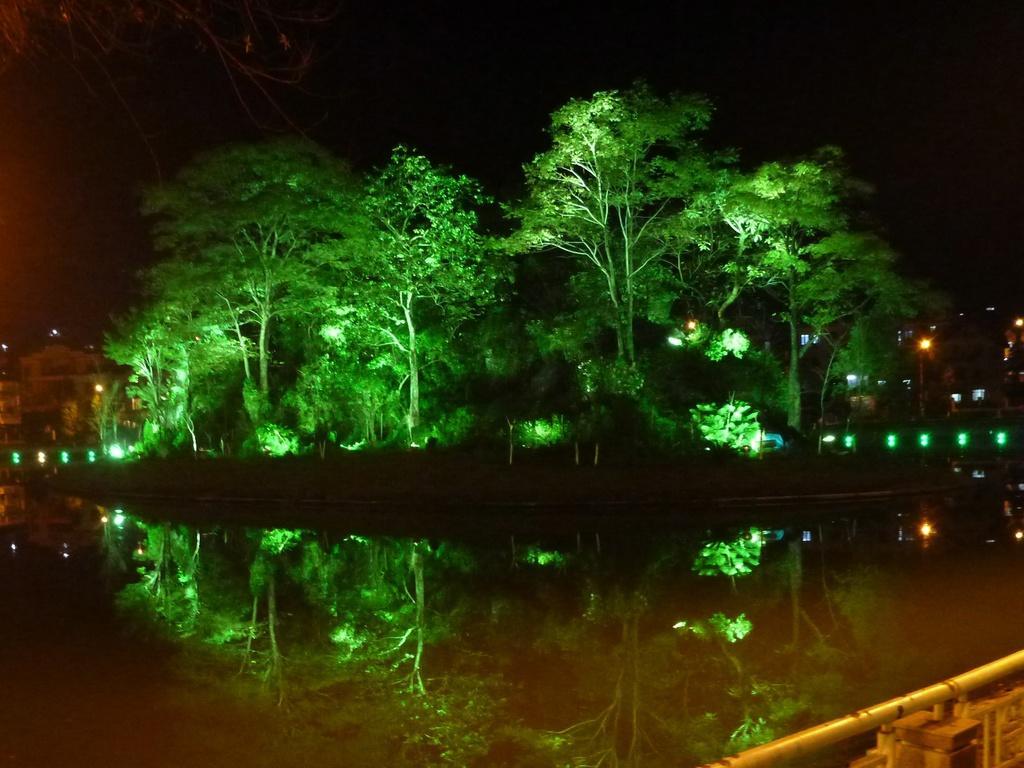Can you describe this image briefly? In this picture we can see water, trees and lights. Behind the trees there is a sky. 